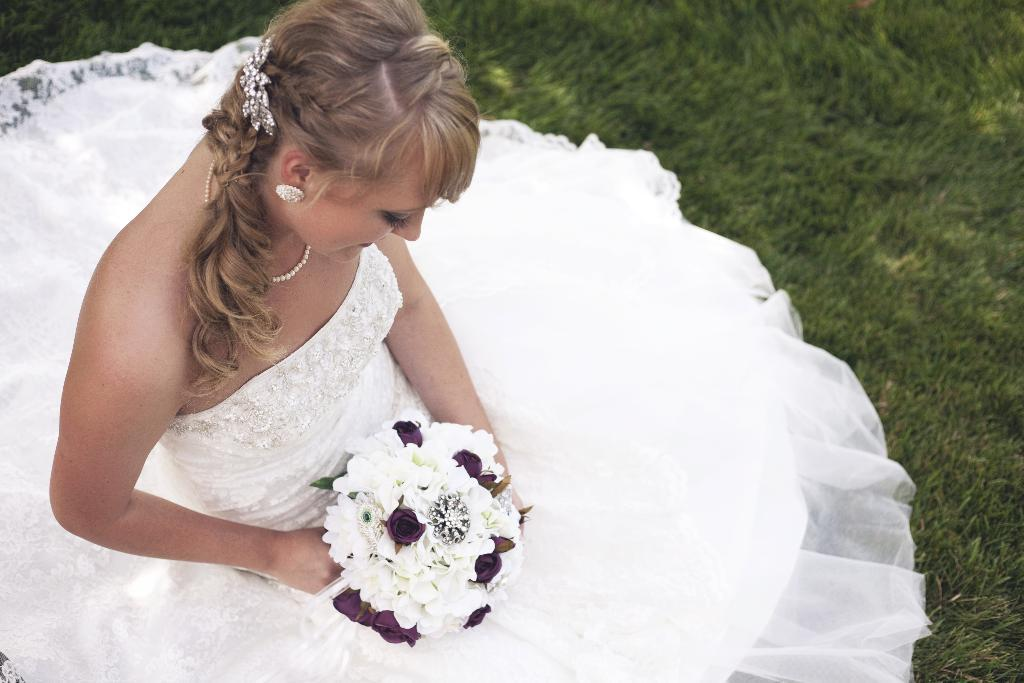Who is the main subject in the image? There is a girl in the image. Where is the girl sitting in the image? The girl is sitting on the left side of the image. What type of surface is the girl sitting on? The girl is sitting on the grassland. What is the girl holding in her hands? The girl is holding flowers in her hands. What type of stage can be seen in the background of the image? There is no stage present in the image; it features a girl sitting on the grassland holding flowers. Can you see any ants crawling on the girl's feet in the image? There is no indication of ants in the image; it only shows a girl sitting on the grassland holding flowers. 